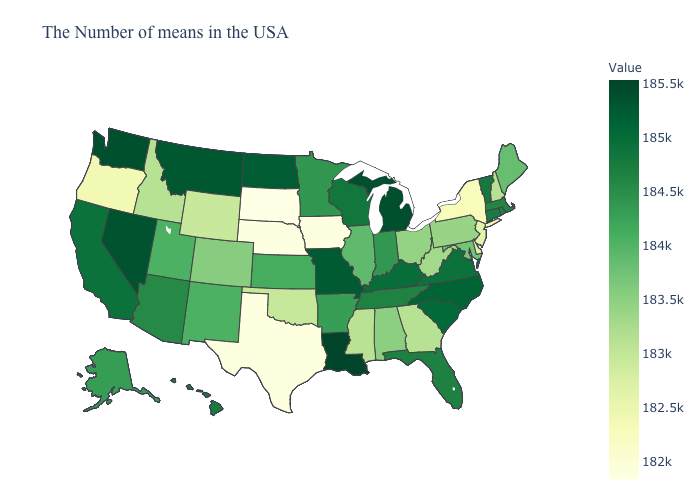Does the map have missing data?
Concise answer only. No. Which states have the lowest value in the USA?
Write a very short answer. South Dakota. Does Idaho have the lowest value in the USA?
Give a very brief answer. No. Among the states that border Kentucky , does Ohio have the lowest value?
Short answer required. No. 